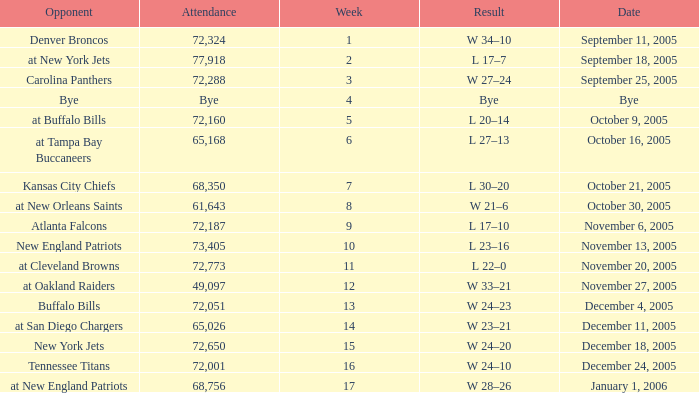What is the Date of the game with an attendance of 72,051 after Week 9? December 4, 2005. 